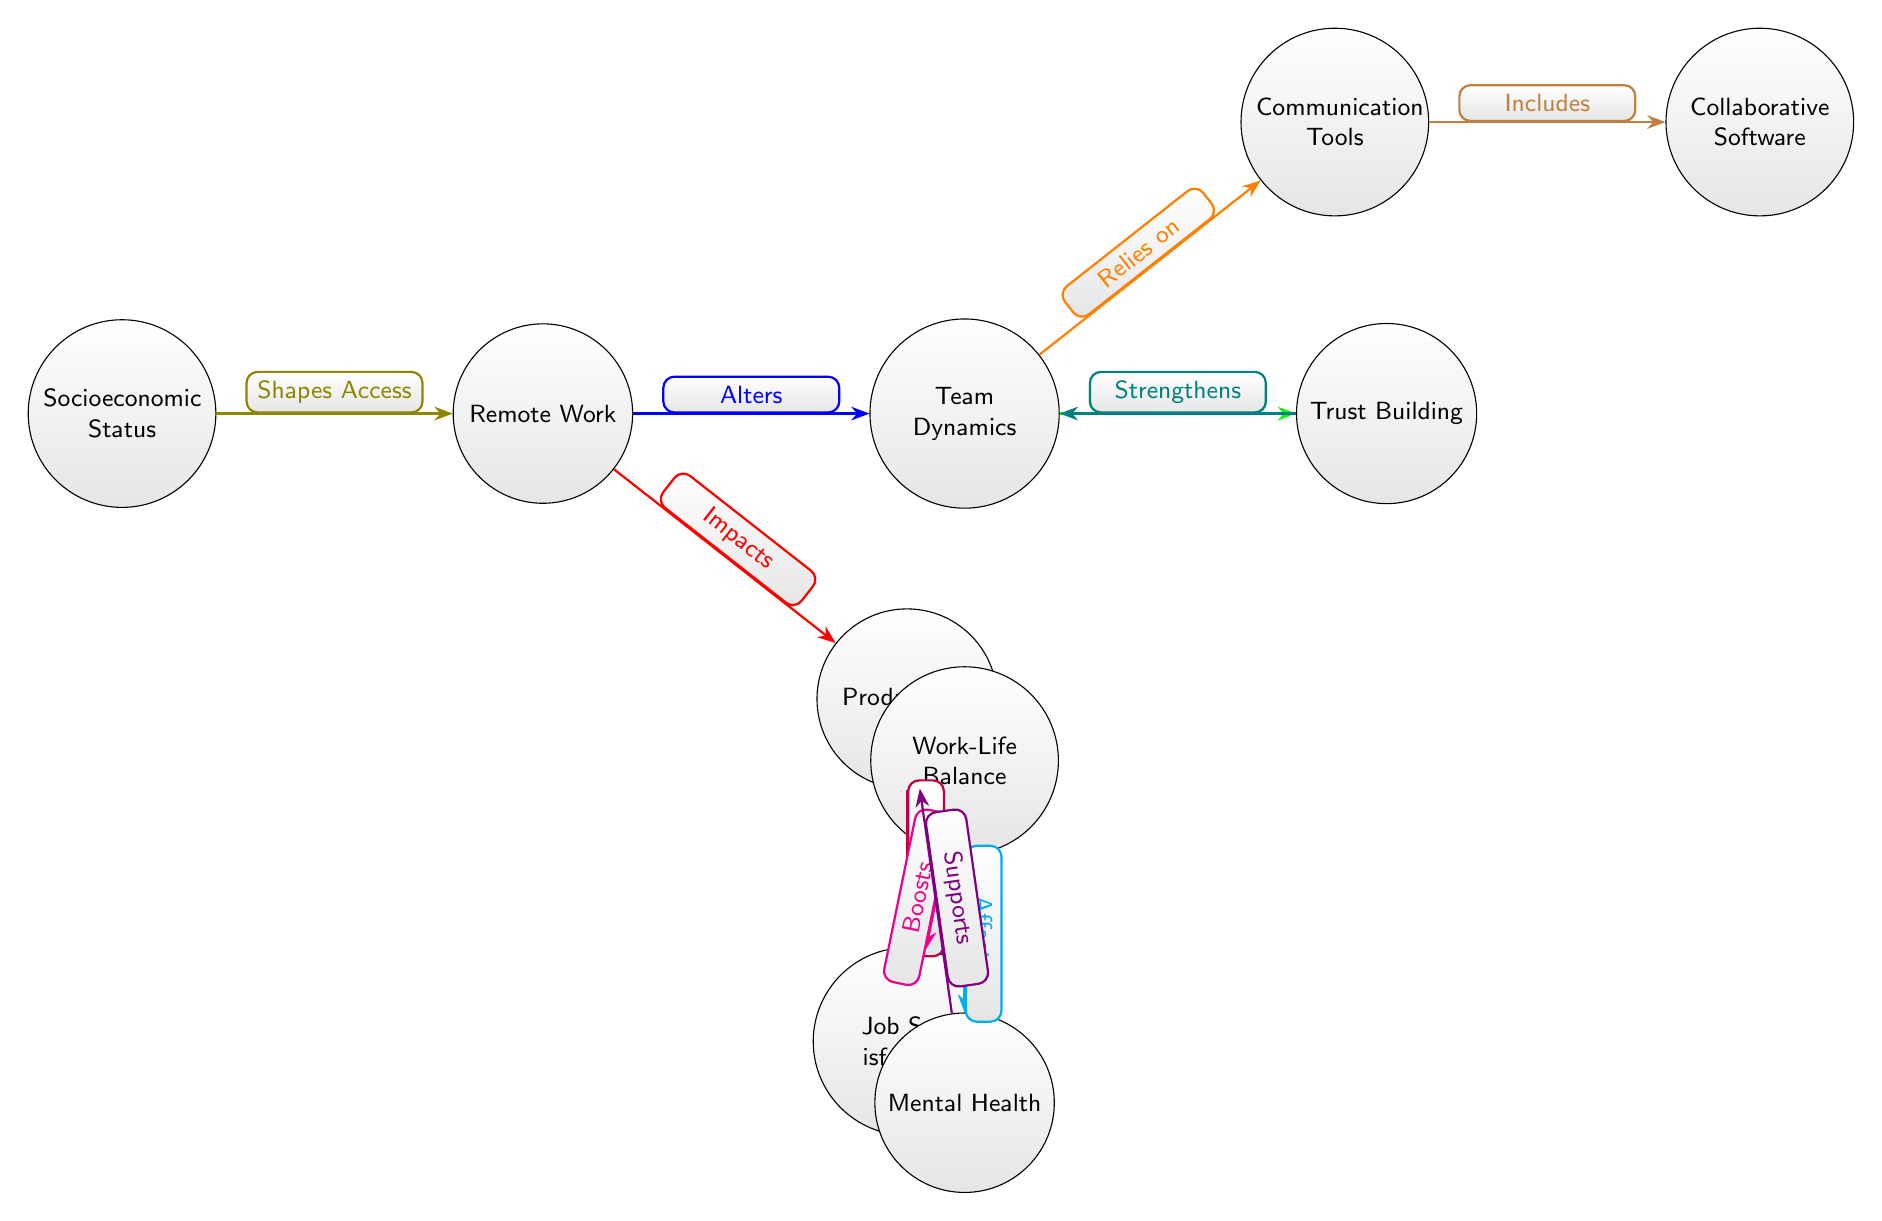What is the central node in the diagram? The central node in the diagram is "Remote Work," which connects to other nodes, indicating it as a primary factor affecting team dynamics and productivity.
Answer: Remote Work How many total nodes are in the diagram? Counting all the unique categories represented, the diagram contains ten nodes, each depicting various aspects related to the impact of remote work.
Answer: 10 Which node directly influences "Trust Building"? The node that directly influences "Trust Building" is "Team Dynamics," suggesting that the dynamics within the team play a crucial role in building trust among team members.
Answer: Team Dynamics What is the relationship between "Work-Life Balance" and "Mental Health"? The relationship is that "Work-Life Balance" affects "Mental Health," meaning that a healthy work-life balance contributes positively to one’s mental health status.
Answer: Affects Which element boosts "Job Satisfaction"? "Work-Life Balance" boosts "Job Satisfaction," emphasizing the importance of balancing work and personal life as a contributor to job satisfaction levels.
Answer: Boosts How does "Communication Tools" relate to "Collaborative Software"? "Communication Tools" includes "Collaborative Software," indicating that collaborative tools are part of the broader category of communication aids used in remote work.
Answer: Includes What impact does "Remote Work" have on "Productivity"? "Remote Work" impacts "Productivity" by causing changes that may enhance or hinder productivity levels, illustrating its significant influence in this context.
Answer: Impacts Which node shapes access to "Remote Work"? "Socioeconomic Status" shapes access to "Remote Work," highlighting how a person's socioeconomic background can affect their ability to work remotely.
Answer: Shapes Access How is "Job Satisfaction" affected by both "Productivity" and "Work-Life Balance"? "Job Satisfaction" is enhanced by "Productivity" and is also boosted by "Work-Life Balance." Thus, it is positively influenced by both nodes, leading to overall job contentment.
Answer: Enhanced, Boosts 